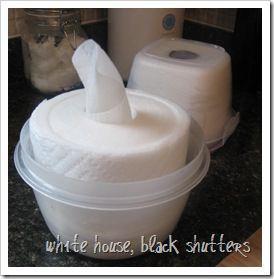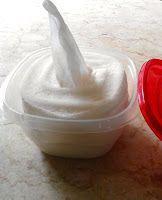The first image is the image on the left, the second image is the image on the right. Considering the images on both sides, is "The container in the image on the right is round." valid? Answer yes or no. No. 